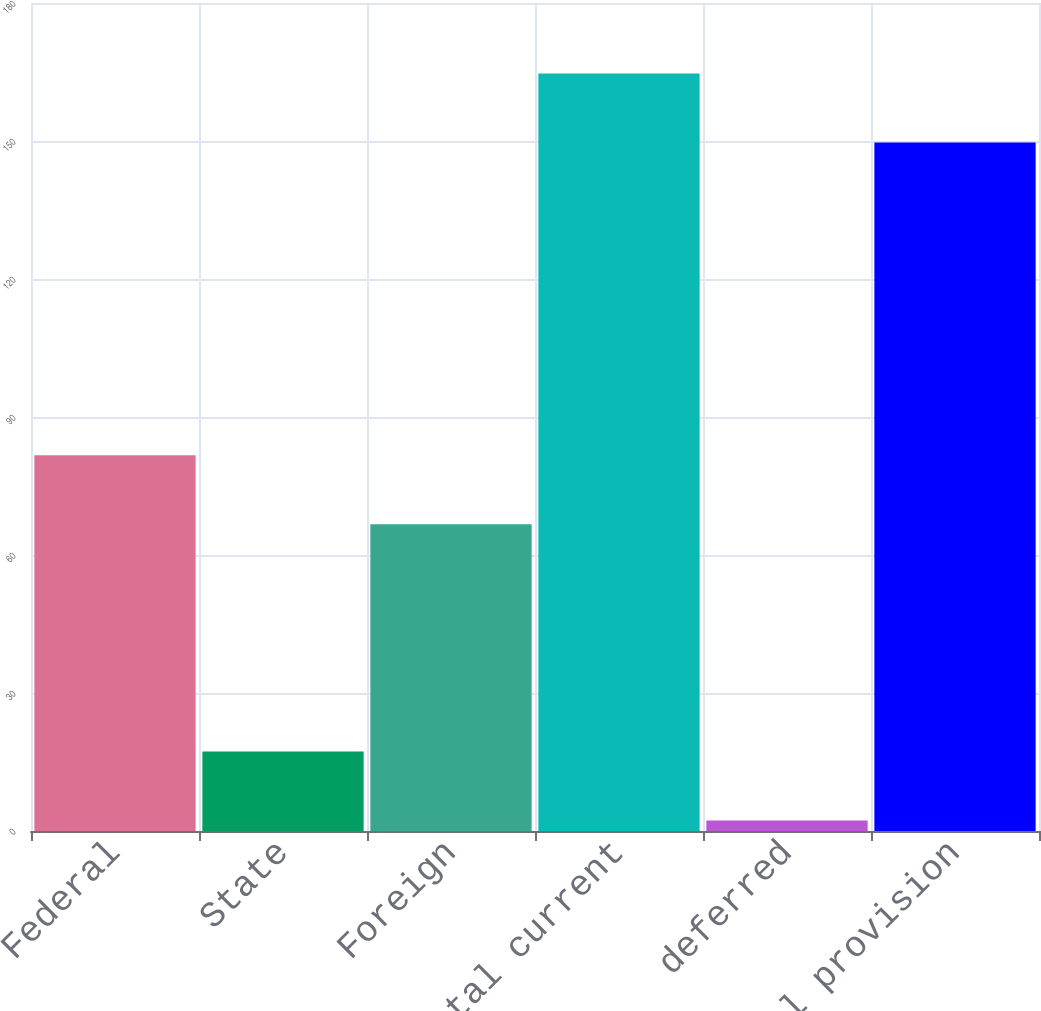<chart> <loc_0><loc_0><loc_500><loc_500><bar_chart><fcel>Federal<fcel>State<fcel>Foreign<fcel>total current<fcel>deferred<fcel>total provision<nl><fcel>81.67<fcel>17.27<fcel>66.7<fcel>164.67<fcel>2.3<fcel>149.7<nl></chart> 